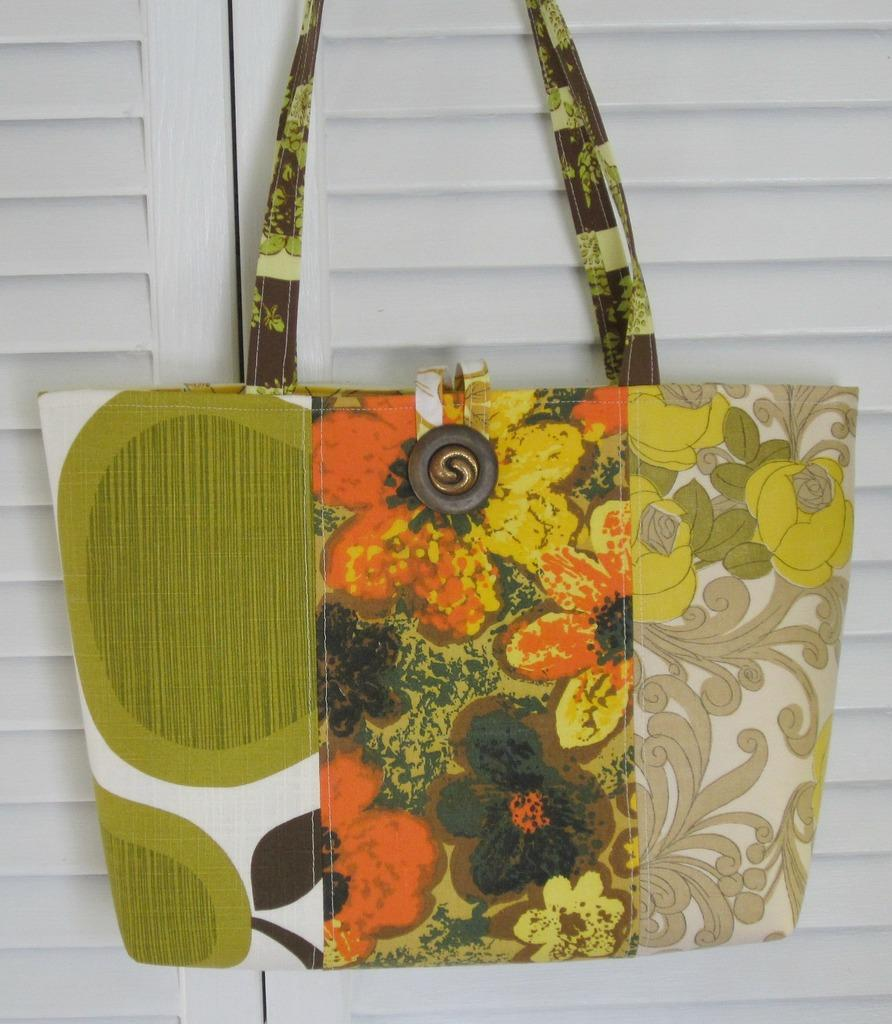What is present in the image? There is a bag in the image. How is the bag positioned? The bag is hung. What can be seen at the center of the bag? There are flowers at the center of the bag. What is the baby's opinion about the bag in the image? There is no baby present in the image, so it is not possible to determine their opinion about the bag. 